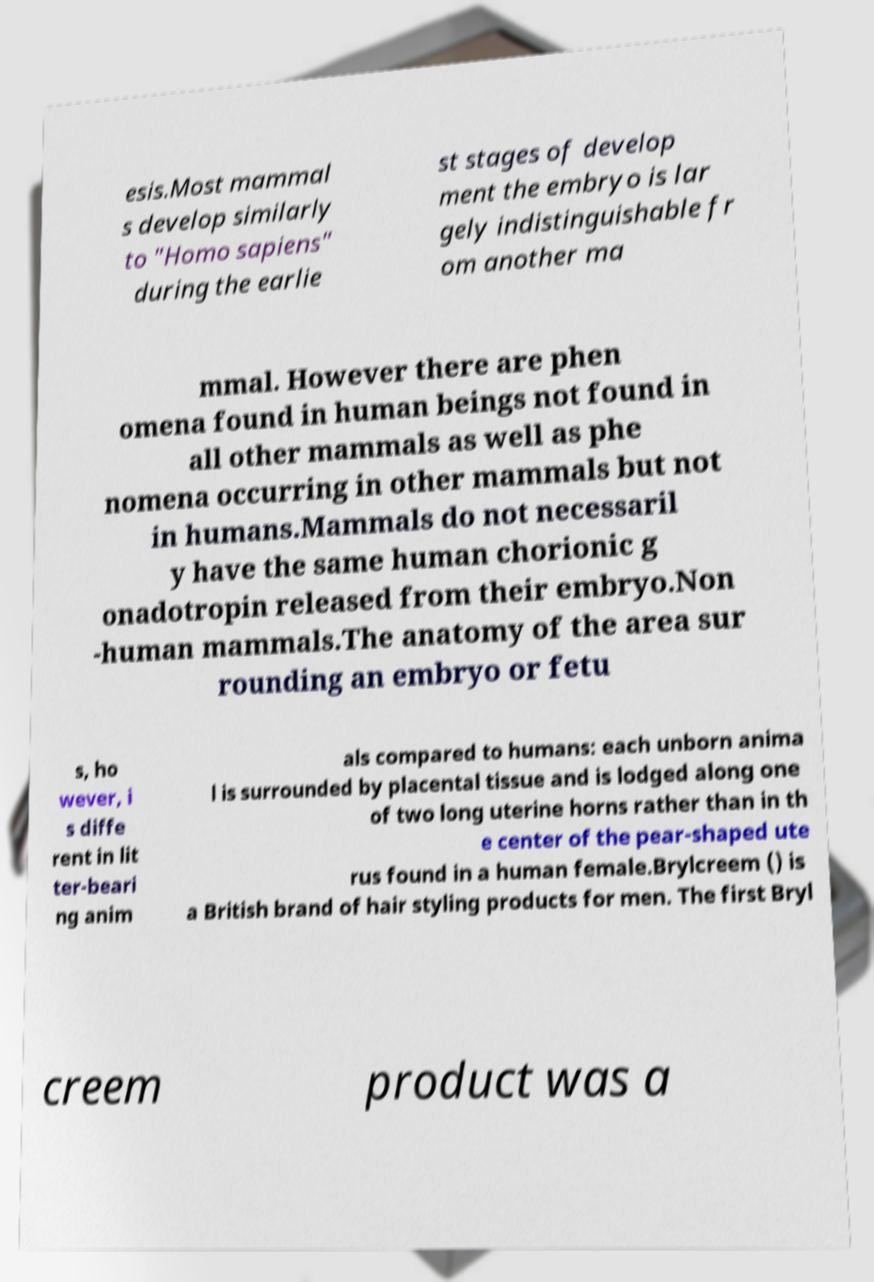Can you read and provide the text displayed in the image?This photo seems to have some interesting text. Can you extract and type it out for me? esis.Most mammal s develop similarly to "Homo sapiens" during the earlie st stages of develop ment the embryo is lar gely indistinguishable fr om another ma mmal. However there are phen omena found in human beings not found in all other mammals as well as phe nomena occurring in other mammals but not in humans.Mammals do not necessaril y have the same human chorionic g onadotropin released from their embryo.Non -human mammals.The anatomy of the area sur rounding an embryo or fetu s, ho wever, i s diffe rent in lit ter-beari ng anim als compared to humans: each unborn anima l is surrounded by placental tissue and is lodged along one of two long uterine horns rather than in th e center of the pear-shaped ute rus found in a human female.Brylcreem () is a British brand of hair styling products for men. The first Bryl creem product was a 